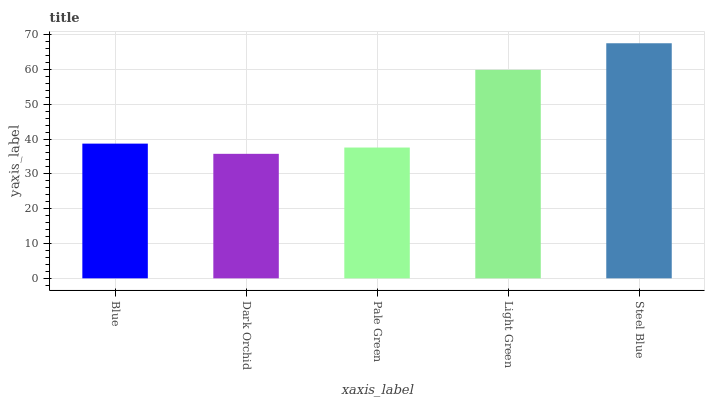Is Dark Orchid the minimum?
Answer yes or no. Yes. Is Steel Blue the maximum?
Answer yes or no. Yes. Is Pale Green the minimum?
Answer yes or no. No. Is Pale Green the maximum?
Answer yes or no. No. Is Pale Green greater than Dark Orchid?
Answer yes or no. Yes. Is Dark Orchid less than Pale Green?
Answer yes or no. Yes. Is Dark Orchid greater than Pale Green?
Answer yes or no. No. Is Pale Green less than Dark Orchid?
Answer yes or no. No. Is Blue the high median?
Answer yes or no. Yes. Is Blue the low median?
Answer yes or no. Yes. Is Pale Green the high median?
Answer yes or no. No. Is Steel Blue the low median?
Answer yes or no. No. 